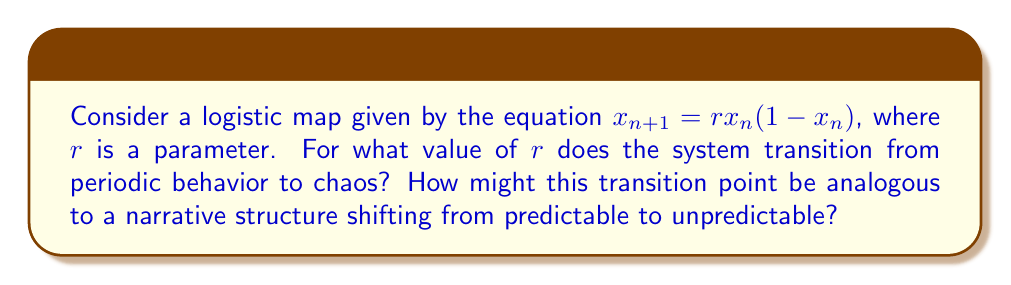Can you solve this math problem? To analyze the chaotic behavior of the logistic map and its implications for unpredictable narrative structures, we'll follow these steps:

1) The logistic map is defined by the equation:
   $$x_{n+1} = rx_n(1-x_n)$$
   where $r$ is a parameter that controls the behavior of the system.

2) As $r$ increases, the system undergoes a series of period-doubling bifurcations:
   - For $0 < r < 3$, the system converges to a fixed point.
   - At $r = 3$, the system undergoes its first period-doubling bifurcation.
   - As $r$ increases further, the system undergoes more period-doubling bifurcations.

3) The transition to chaos occurs at the accumulation point of these period-doubling bifurcations. This point is known as the Feigenbaum point, named after Mitchell Feigenbaum who discovered it.

4) The Feigenbaum point occurs at approximately:
   $$r \approx 3.56994567187094490184200515138$$

5) Beyond this point, the system exhibits chaotic behavior, with some windows of periodic behavior interspersed.

6) In terms of narrative structure, this transition point can be seen as analogous to the point where a story shifts from a predictable, linear progression to a more complex, unpredictable structure:
   - Below the Feigenbaum point: The narrative follows a clear, periodic structure (like a traditional three-act structure).
   - At the Feigenbaum point: The narrative begins to branch into multiple possible paths or interpretations.
   - Beyond the Feigenbaum point: The narrative becomes highly sensitive to initial conditions, with small changes leading to vastly different outcomes or interpretations, much like in postmodern or experimental literature.
Answer: $r \approx 3.56994567187094490184200515138$ (Feigenbaum point) 